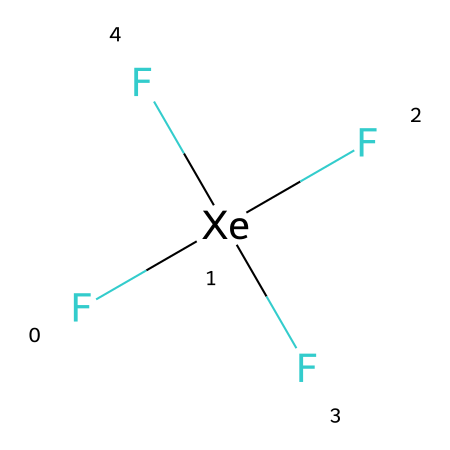What is the name of this compound? The SMILES representation indicates that this compound consists of one xenon atom bonded with four fluorine atoms. The name of this compound is derived from its composition, which includes xenon and fluorine.
Answer: xenon tetrafluoride How many fluorine atoms are present? The SMILES representation shows four fluorine (F) atoms connected to the xenon (Xe) atom, indicated by the four F atoms in parentheses connected to Xe.
Answer: four Is xenon in this compound hypervalent? To determine if xenon is hypervalent, we need to see the number of bonds it forms. In this case, xenon forms four bonds with four fluorine atoms, surpassing the octet rule. Therefore, xenon has expanded its valence shell to accommodate more than eight electrons.
Answer: yes What type of element is xenon? Xenon is classified as a noble gas, which is indicated by its position in the periodic table. Noble gases are known for their lack of reactivity and complete valence shells.
Answer: noble gas What is the hybridization of xenon in xenon tetrafluoride? To deduce the hybridization, we analyze the bonding and the number of electron groups around the xenon atom. Xenon, sharing four bonds with fluorine atoms, exhibits sp³d hybridization, which corresponds to five total electron groups (four bonds, and one lone pair).
Answer: sp³d What geometry does xenon tetrafluoride conform to? The arrangement of bonding pairs and lone pairs around the xenon atom helps determine its molecular geometry. With four bonding pairs and one lone pair, the geometry corresponds to a square pyramidal shape, consistent with sp³d hybridization.
Answer: square pyramidal 